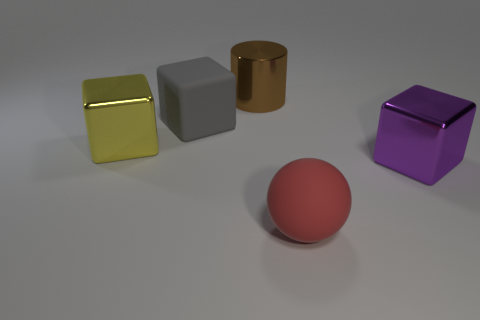What number of yellow metallic things have the same shape as the gray object?
Offer a very short reply. 1. There is a object that is right of the thing that is in front of the metal object to the right of the big red matte thing; how big is it?
Give a very brief answer. Large. Does the block that is in front of the large yellow thing have the same material as the gray cube?
Your response must be concise. No. Are there the same number of big yellow metal objects behind the gray matte block and large brown cylinders on the right side of the big matte sphere?
Offer a terse response. Yes. There is a yellow object that is the same shape as the big purple object; what material is it?
Your response must be concise. Metal. There is a large metal thing that is in front of the metallic block that is on the left side of the large purple thing; is there a large shiny cylinder that is in front of it?
Ensure brevity in your answer.  No. Does the gray object in front of the brown metal thing have the same shape as the shiny thing on the left side of the big gray object?
Ensure brevity in your answer.  Yes. Is the number of metallic blocks that are on the left side of the brown metallic thing greater than the number of small yellow matte cylinders?
Give a very brief answer. Yes. How many objects are either large purple objects or brown cylinders?
Your response must be concise. 2. What is the color of the sphere?
Ensure brevity in your answer.  Red. 